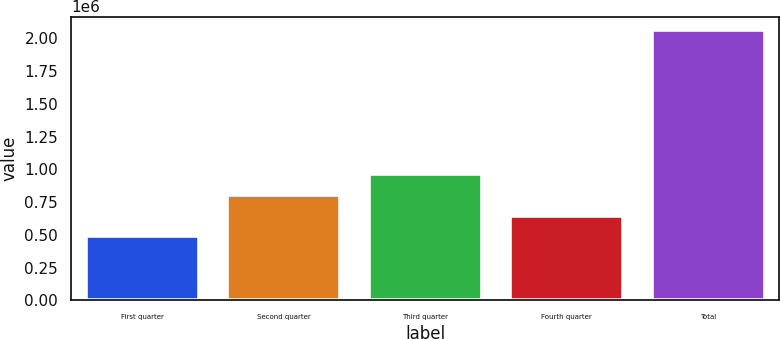<chart> <loc_0><loc_0><loc_500><loc_500><bar_chart><fcel>First quarter<fcel>Second quarter<fcel>Third quarter<fcel>Fourth quarter<fcel>Total<nl><fcel>489157<fcel>803689<fcel>960956<fcel>646423<fcel>2.06182e+06<nl></chart> 